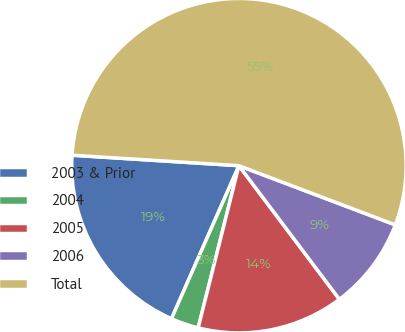Convert chart to OTSL. <chart><loc_0><loc_0><loc_500><loc_500><pie_chart><fcel>2003 & Prior<fcel>2004<fcel>2005<fcel>2006<fcel>Total<nl><fcel>19.39%<fcel>2.69%<fcel>14.18%<fcel>8.98%<fcel>54.76%<nl></chart> 